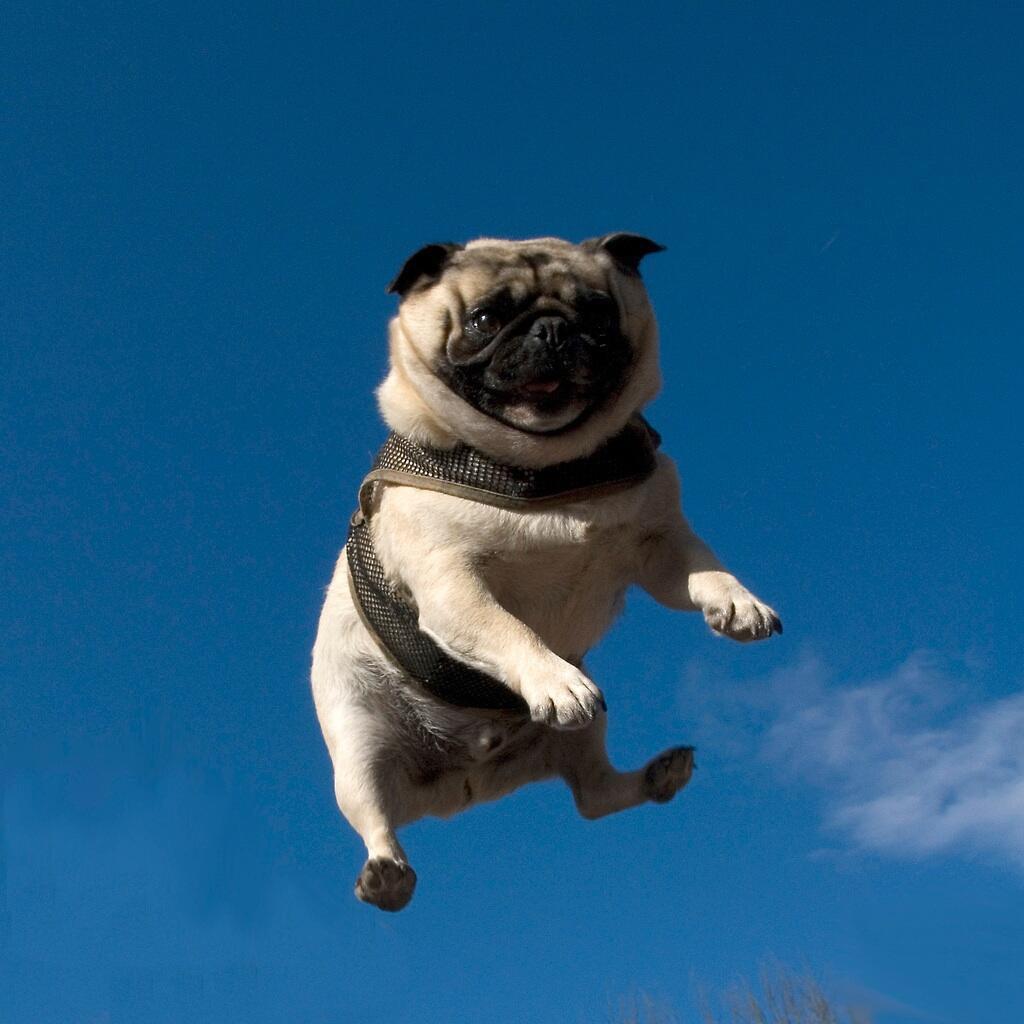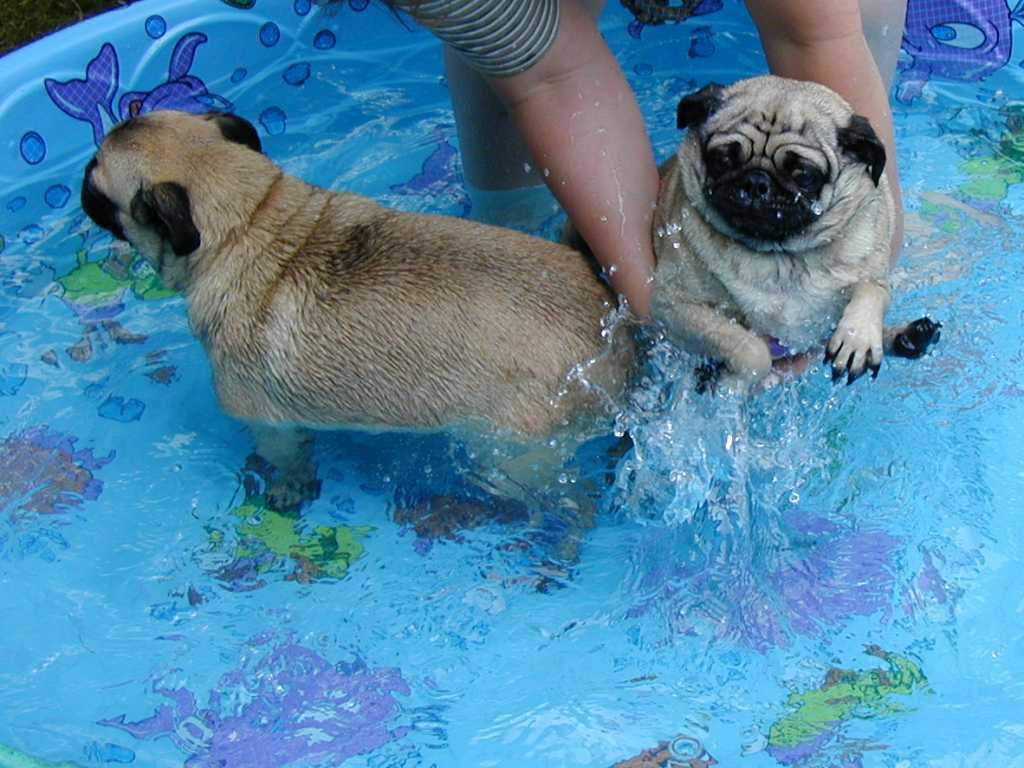The first image is the image on the left, the second image is the image on the right. Considering the images on both sides, is "Only one of the images shows a dog in the water." valid? Answer yes or no. Yes. The first image is the image on the left, the second image is the image on the right. Assess this claim about the two images: "In both of the images there is a dog in a swimming pool.". Correct or not? Answer yes or no. No. 